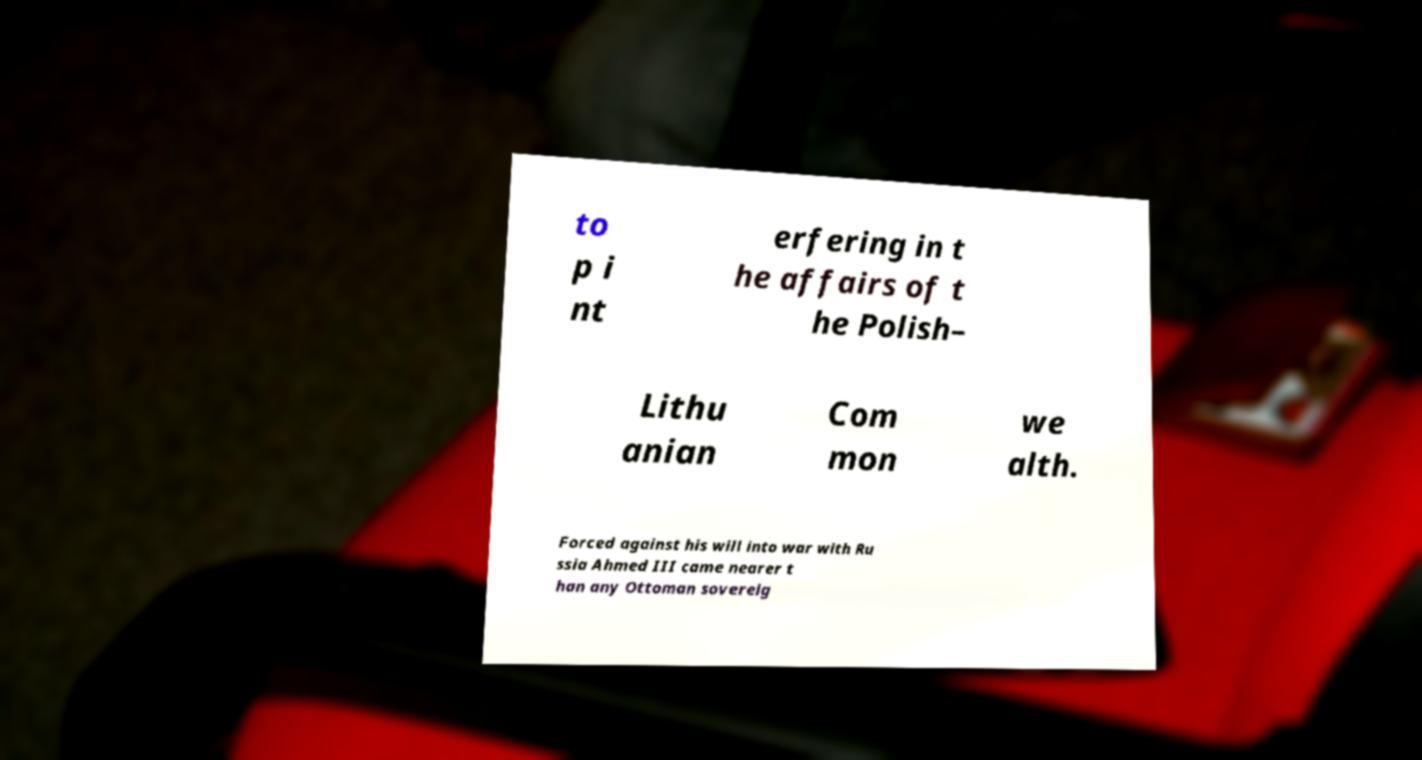What messages or text are displayed in this image? I need them in a readable, typed format. to p i nt erfering in t he affairs of t he Polish– Lithu anian Com mon we alth. Forced against his will into war with Ru ssia Ahmed III came nearer t han any Ottoman sovereig 